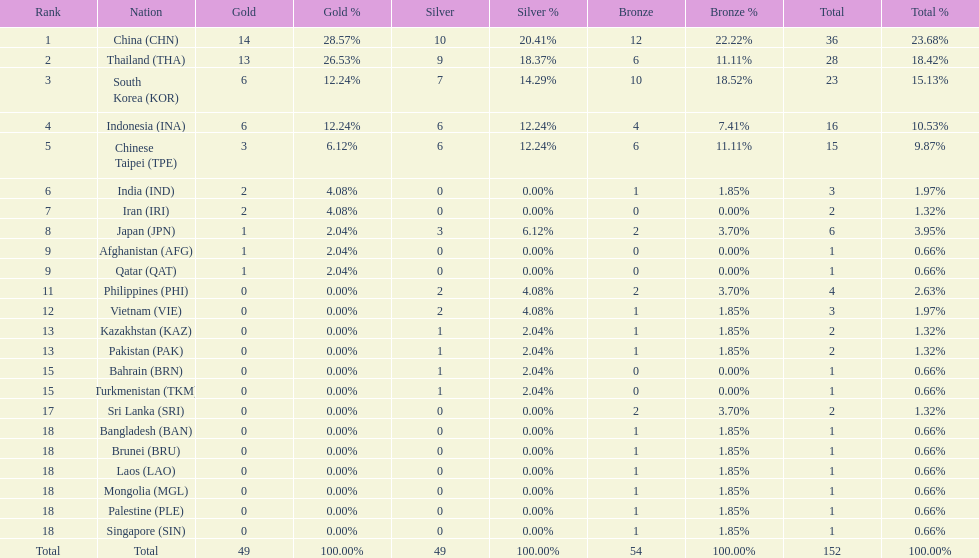How many nations received more than 5 gold medals? 4. 